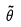Convert formula to latex. <formula><loc_0><loc_0><loc_500><loc_500>\tilde { \theta }</formula> 